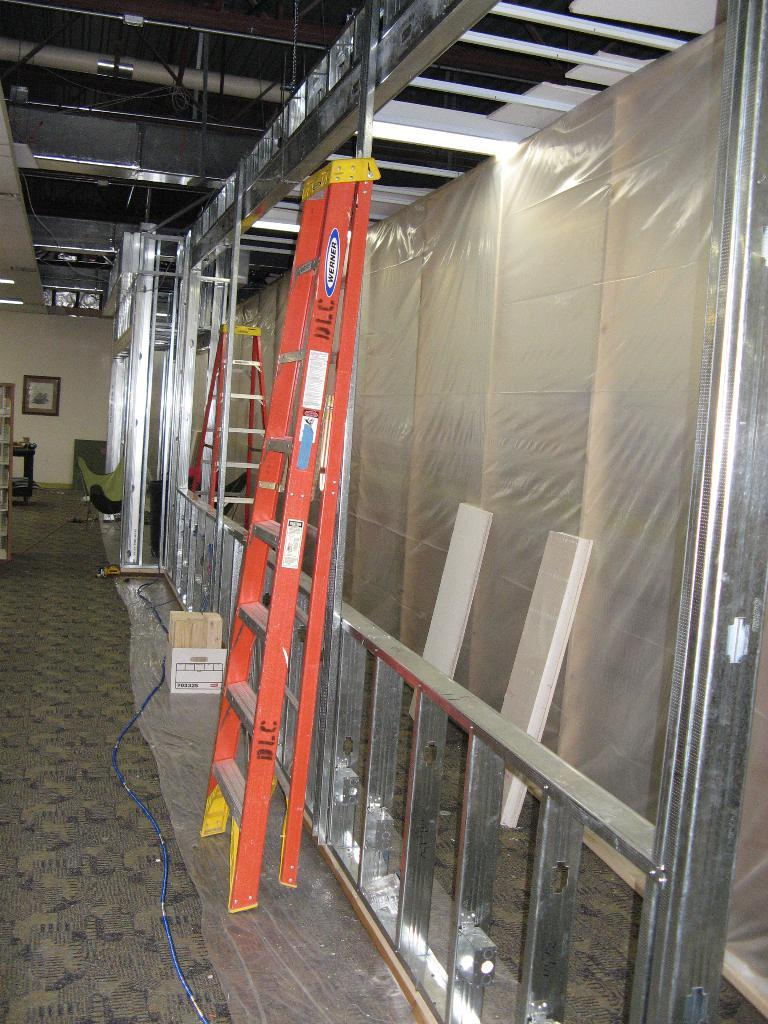Where is the image taken? The image is inside a home store. What type of item can be seen in the image? There are metal ladders in the image. What type of mask is being used to crush the grain in the image? There is no mask or grain present in the image; it only features metal ladders. 